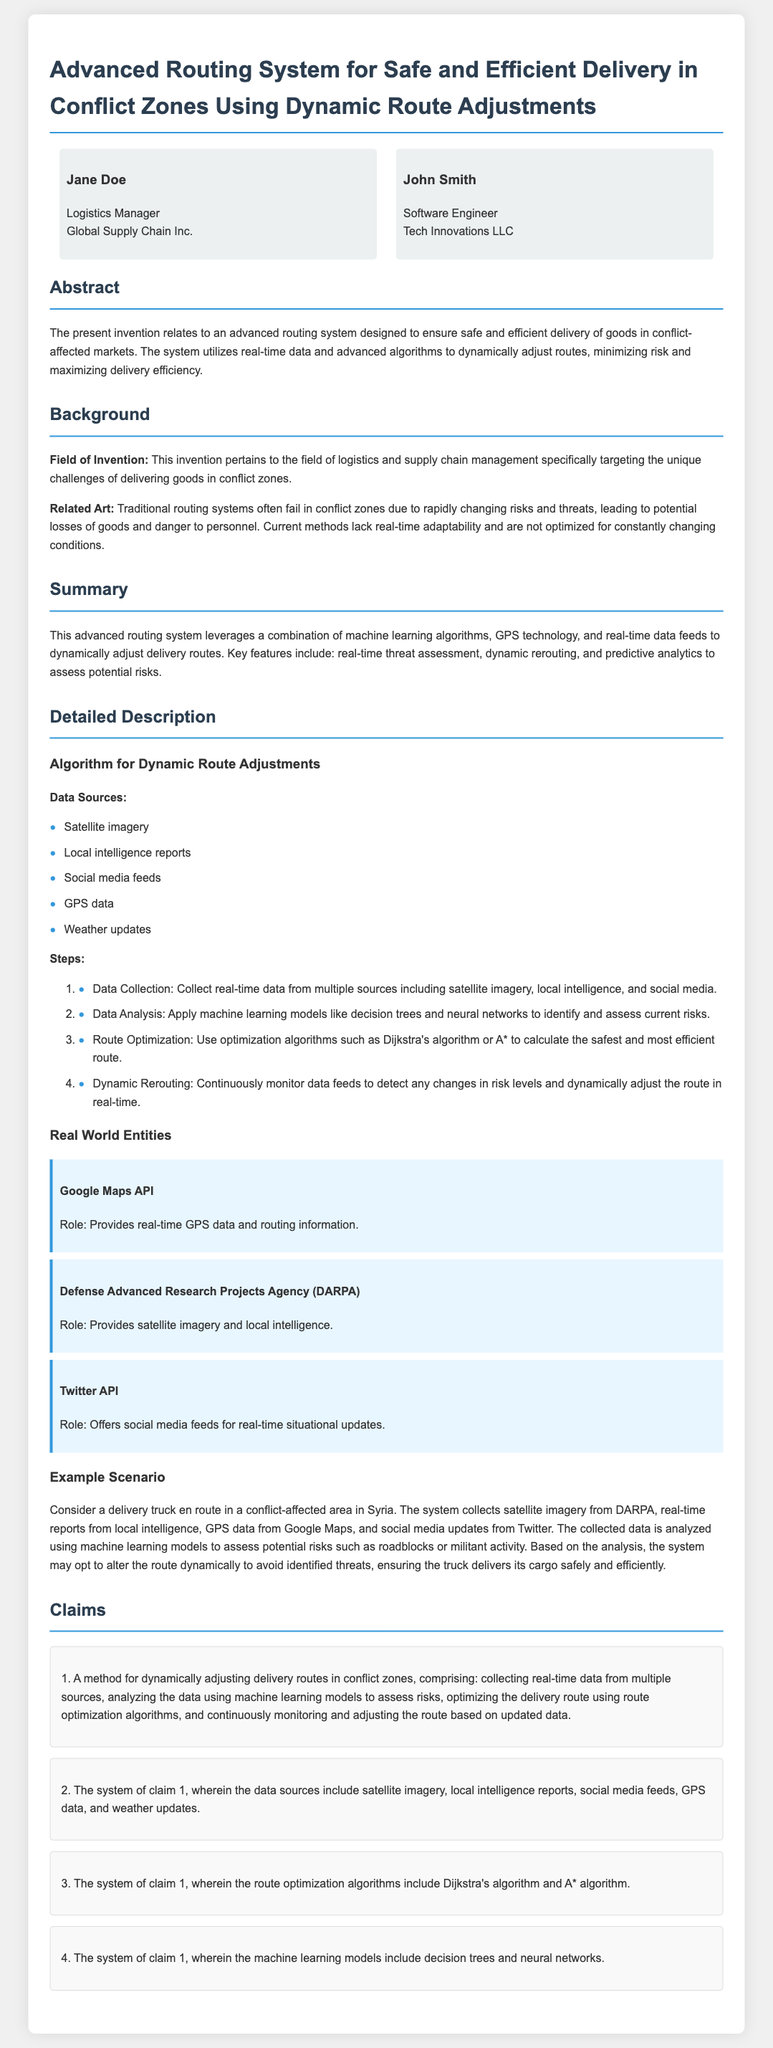What is the title of the patent application? The title of the patent application is prominently displayed at the top of the document.
Answer: Advanced Routing System for Safe and Efficient Delivery in Conflict Zones Using Dynamic Route Adjustments Who are the inventors listed in the document? The document provides names and roles of the inventors in a section; there are two inventors mentioned.
Answer: Jane Doe and John Smith What is the primary focus of this invention? The abstract highlights the invention's aim to address specific delivery challenges in certain areas.
Answer: Safe and efficient delivery Which machine learning models are mentioned for data analysis? The detailed description mentions specific models used to analyze data in the routing system.
Answer: Decision trees and neural networks What type of data does the system leverage for route adjustments? A specific list of data sources is provided, indicating what the system uses to make assessments.
Answer: Satellite imagery, local intelligence reports, social media feeds, GPS data, and weather updates What key algorithm is noted for route optimization? The document outlines algorithms used for optimizing routes in conflict zones; this is one of the main components of the process.
Answer: Dijkstra's algorithm and A* algorithm What unique challenge does the invention aim to solve? The background section describes current limitations in traditional systems that often fail under specific circumstances.
Answer: Rapidly changing risks and threats What kind of scenario is provided as an example? The detailed description includes a specific situation to illustrate how the system works in the real world.
Answer: A delivery truck in a conflict-affected area in Syria 